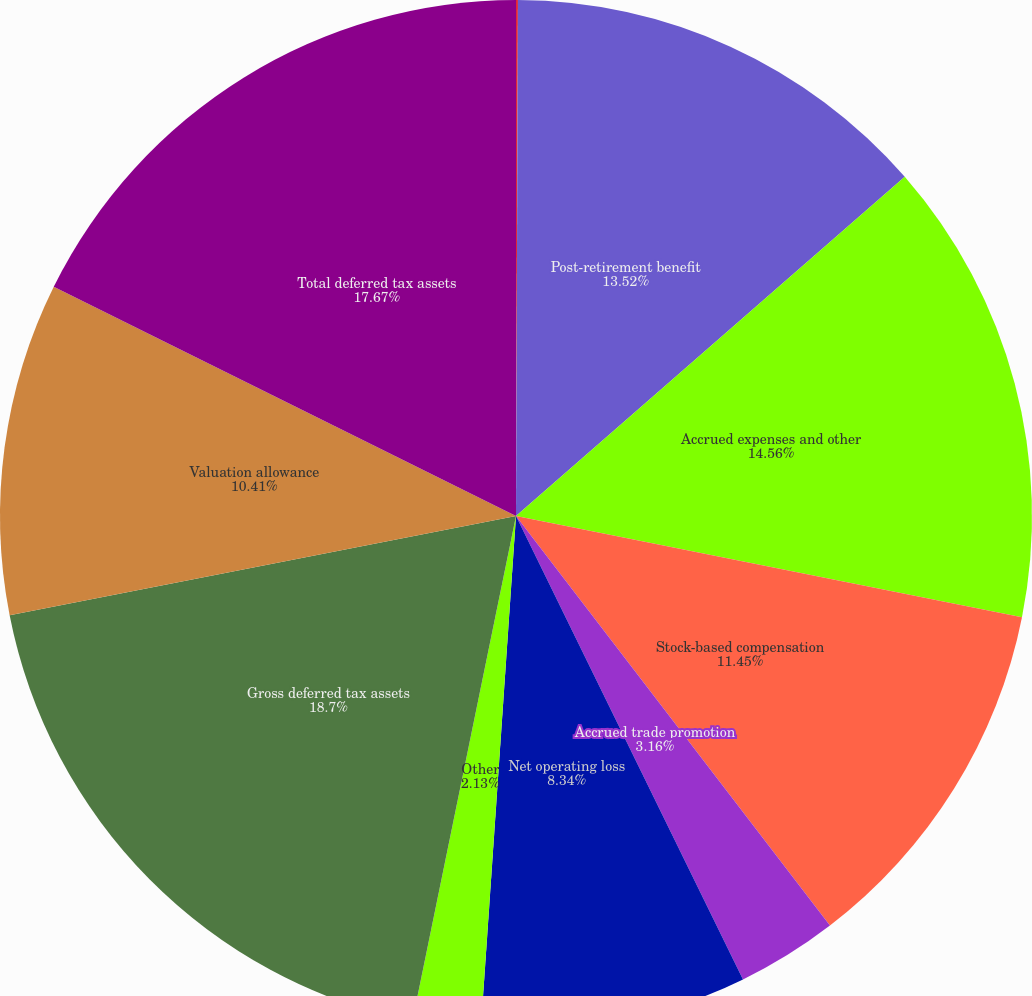Convert chart. <chart><loc_0><loc_0><loc_500><loc_500><pie_chart><fcel>December 31<fcel>Post-retirement benefit<fcel>Accrued expenses and other<fcel>Stock-based compensation<fcel>Accrued trade promotion<fcel>Net operating loss<fcel>Other<fcel>Gross deferred tax assets<fcel>Valuation allowance<fcel>Total deferred tax assets<nl><fcel>0.06%<fcel>13.52%<fcel>14.56%<fcel>11.45%<fcel>3.16%<fcel>8.34%<fcel>2.13%<fcel>18.7%<fcel>10.41%<fcel>17.67%<nl></chart> 